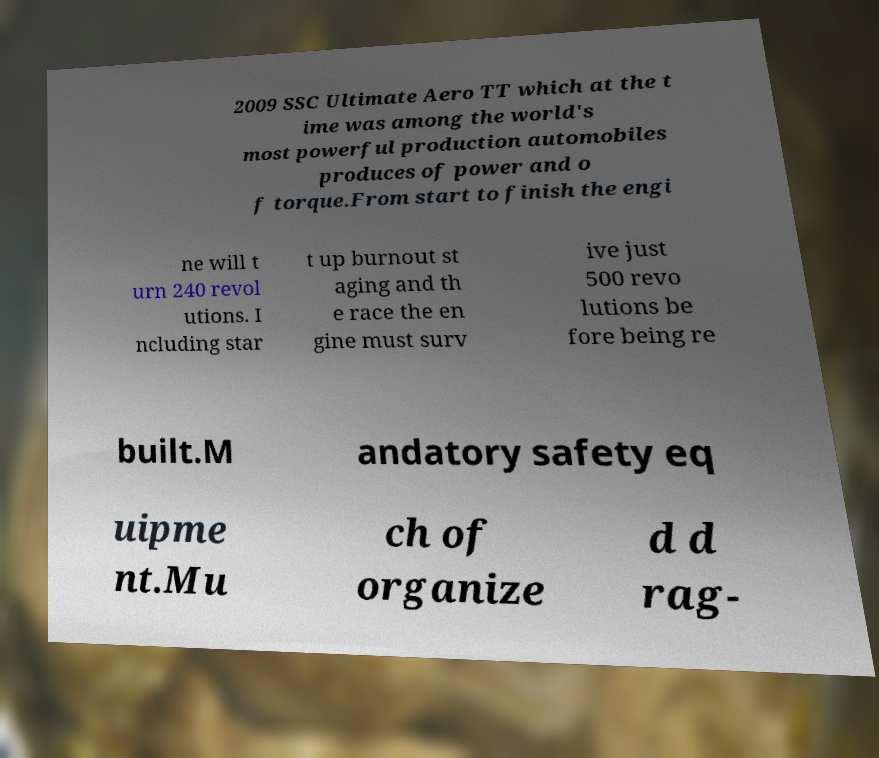For documentation purposes, I need the text within this image transcribed. Could you provide that? 2009 SSC Ultimate Aero TT which at the t ime was among the world's most powerful production automobiles produces of power and o f torque.From start to finish the engi ne will t urn 240 revol utions. I ncluding star t up burnout st aging and th e race the en gine must surv ive just 500 revo lutions be fore being re built.M andatory safety eq uipme nt.Mu ch of organize d d rag- 